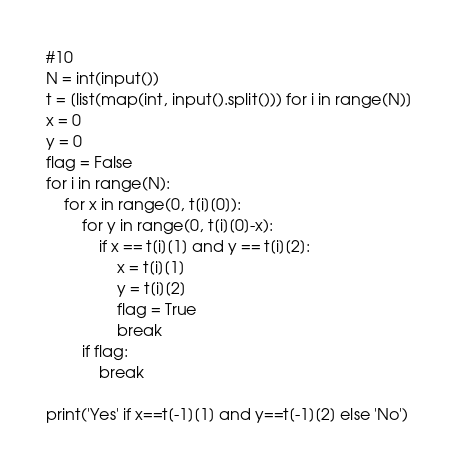<code> <loc_0><loc_0><loc_500><loc_500><_Python_>#10
N = int(input())
t = [list(map(int, input().split())) for i in range(N)]
x = 0
y = 0
flag = False
for i in range(N):
    for x in range(0, t[i][0]):
        for y in range(0, t[i][0]-x):
            if x == t[i][1] and y == t[i][2]:
                x = t[i][1]
                y = t[i][2]
                flag = True
                break
        if flag:
            break

print('Yes' if x==t[-1][1] and y==t[-1][2] else 'No')</code> 